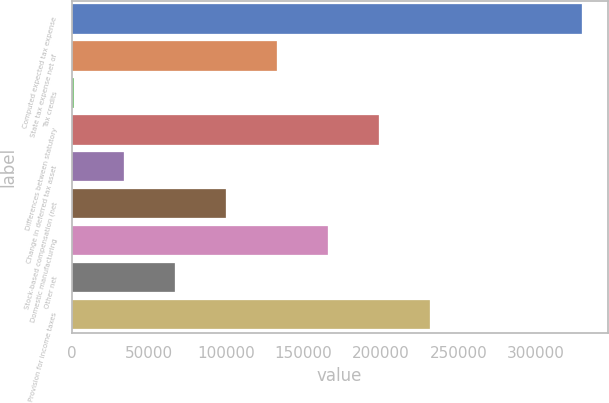Convert chart. <chart><loc_0><loc_0><loc_500><loc_500><bar_chart><fcel>Computed expected tax expense<fcel>State tax expense net of<fcel>Tax credits<fcel>Differences between statutory<fcel>Change in deferred tax asset<fcel>Stock-based compensation (net<fcel>Domestic manufacturing<fcel>Other net<fcel>Provision for income taxes<nl><fcel>330103<fcel>132831<fcel>1317<fcel>198589<fcel>34195.6<fcel>99952.8<fcel>165710<fcel>67074.2<fcel>231467<nl></chart> 